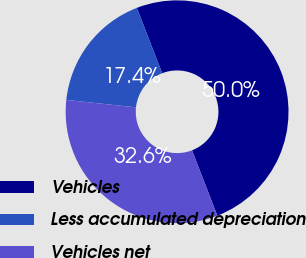Convert chart to OTSL. <chart><loc_0><loc_0><loc_500><loc_500><pie_chart><fcel>Vehicles<fcel>Less accumulated depreciation<fcel>Vehicles net<nl><fcel>50.0%<fcel>17.42%<fcel>32.58%<nl></chart> 